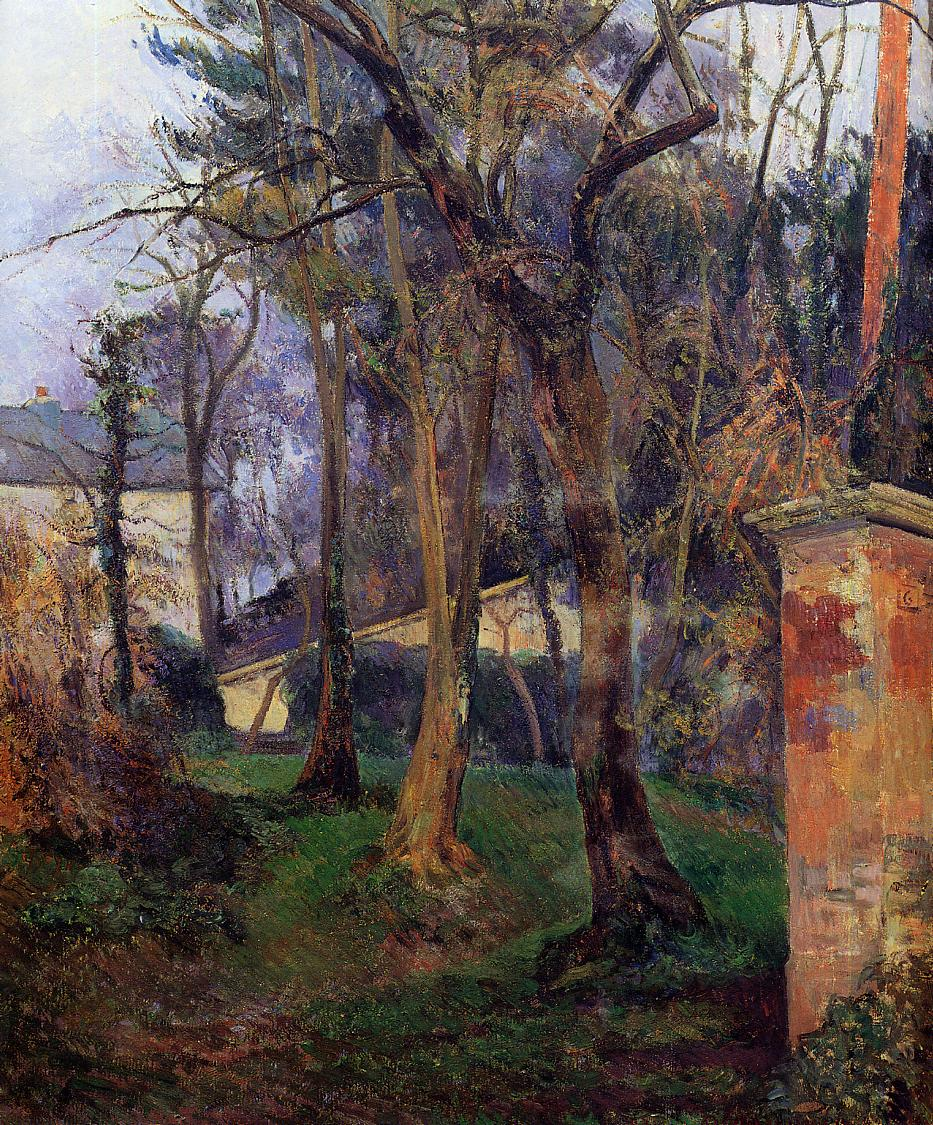Can you suggest what time of day or season this painting might depict? The soft, diffuse lighting and the shadow play in the painting suggest early morning, a time when light gently filters through the trees creating vivid and complex patterns on the ground. The lush greenery and the overall freshness of the colors could indicate that the scene is set in late spring or early summer, capturing the rich vibrancy typical of those seasons. 